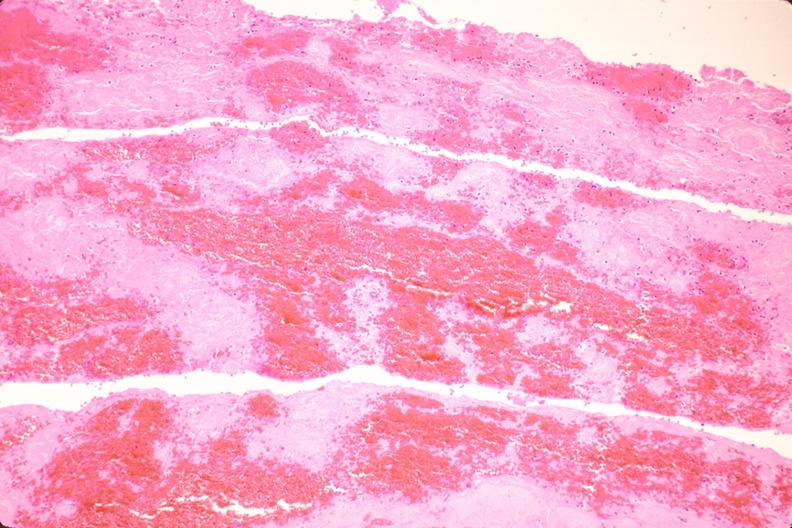does nipple duplication show thromboembolus from leg veins in pulmonary artery?
Answer the question using a single word or phrase. No 